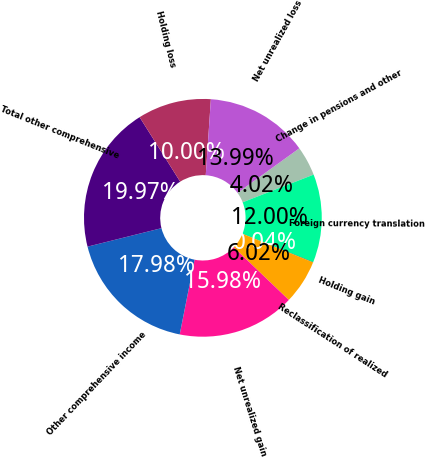<chart> <loc_0><loc_0><loc_500><loc_500><pie_chart><fcel>Change in pensions and other<fcel>Foreign currency translation<fcel>Holding gain<fcel>Reclassification of realized<fcel>Net unrealized gain<fcel>Other comprehensive income<fcel>Total other comprehensive<fcel>Holding loss<fcel>Net unrealized loss<nl><fcel>4.02%<fcel>12.0%<fcel>0.04%<fcel>6.02%<fcel>15.98%<fcel>17.98%<fcel>19.97%<fcel>10.0%<fcel>13.99%<nl></chart> 